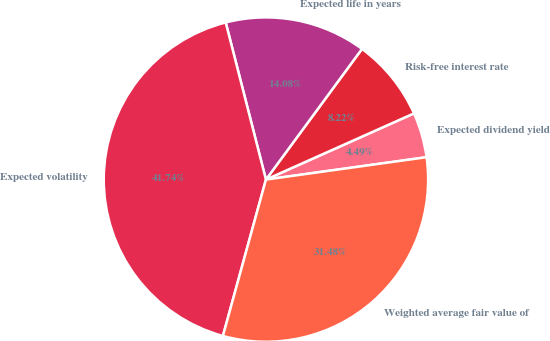Convert chart. <chart><loc_0><loc_0><loc_500><loc_500><pie_chart><fcel>Expected dividend yield<fcel>Risk-free interest rate<fcel>Expected life in years<fcel>Expected volatility<fcel>Weighted average fair value of<nl><fcel>4.49%<fcel>8.22%<fcel>14.08%<fcel>41.74%<fcel>31.48%<nl></chart> 